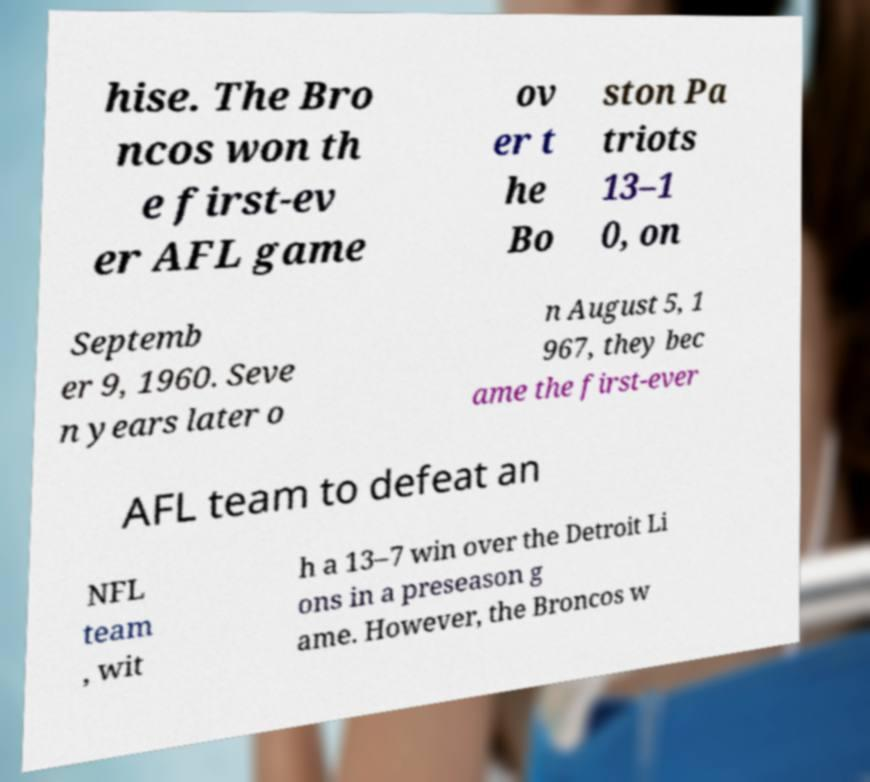Can you read and provide the text displayed in the image?This photo seems to have some interesting text. Can you extract and type it out for me? hise. The Bro ncos won th e first-ev er AFL game ov er t he Bo ston Pa triots 13–1 0, on Septemb er 9, 1960. Seve n years later o n August 5, 1 967, they bec ame the first-ever AFL team to defeat an NFL team , wit h a 13–7 win over the Detroit Li ons in a preseason g ame. However, the Broncos w 